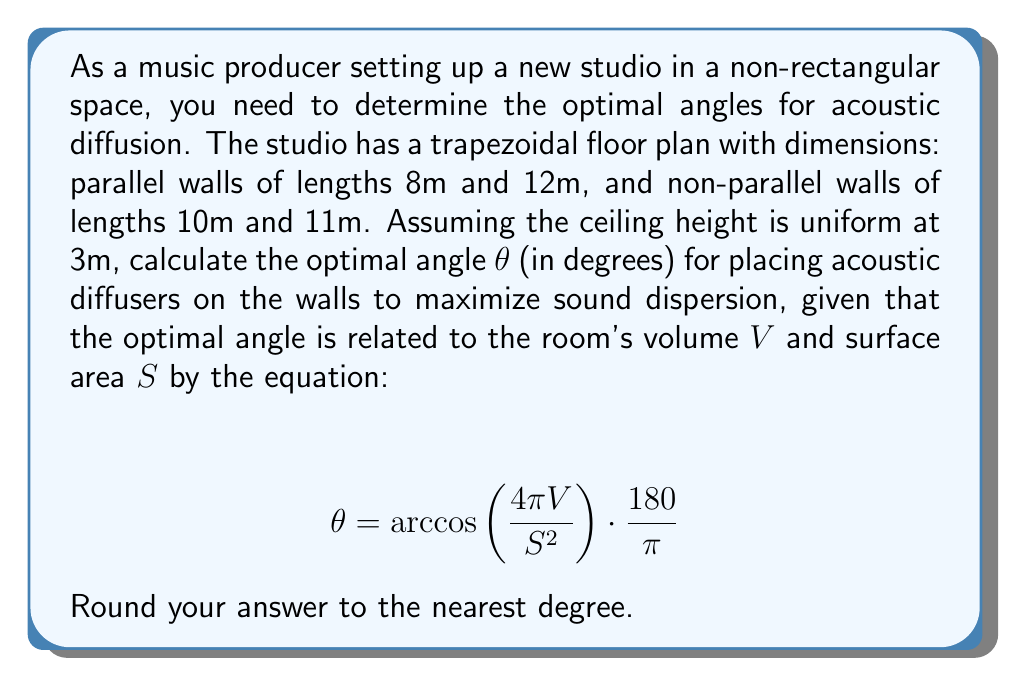Provide a solution to this math problem. To solve this problem, we need to follow these steps:

1. Calculate the floor area of the trapezoidal room
2. Determine the volume of the room
3. Calculate the total surface area of the room
4. Apply the given formula to find the optimal angle

Step 1: Calculate the floor area
The floor is a trapezoid. We can use the formula for trapezoid area:
$$ A = \frac{a + b}{2} \cdot h $$
Where a and b are the parallel sides, and h is the height of the trapezoid.

We need to find h using the Pythagorean theorem:
$$ h^2 + 2^2 = 10^2 $$
$$ h^2 = 100 - 4 = 96 $$
$$ h = \sqrt{96} = 4\sqrt{6} \approx 9.80 \text{m} $$

Now we can calculate the floor area:
$$ A = \frac{8 + 12}{2} \cdot 4\sqrt{6} = 40\sqrt{6} \approx 97.98 \text{m}^2 $$

Step 2: Determine the volume
The volume is the floor area multiplied by the height:
$$ V = 40\sqrt{6} \cdot 3 = 120\sqrt{6} \approx 293.94 \text{m}^3 $$

Step 3: Calculate the total surface area
The surface area includes the floor, ceiling, and all four walls:
$$ S = 2(40\sqrt{6}) + (8 + 12 + 10 + 11) \cdot 3 $$
$$ S = 80\sqrt{6} + 123 \approx 318.96 \text{m}^2 $$

Step 4: Apply the formula
Now we can use the given equation:

$$ \theta = \arccos\left(\frac{4\pi V}{S^2}\right) \cdot \frac{180}{\pi} $$

Substituting our values:

$$ \theta = \arccos\left(\frac{4\pi \cdot 120\sqrt{6}}{(80\sqrt{6} + 123)^2}\right) \cdot \frac{180}{\pi} $$

Using a calculator and rounding to the nearest degree:

$$ \theta \approx 60° $$
Answer: The optimal angle for placing acoustic diffusers in the given non-rectangular studio space is approximately 60°. 